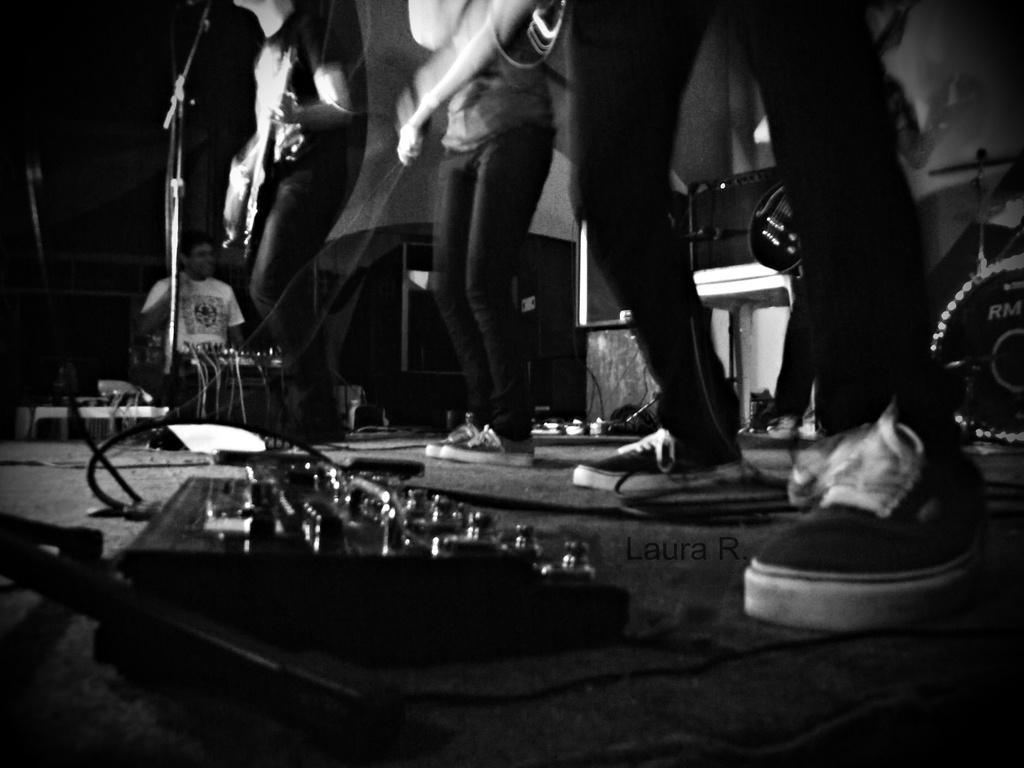Could you give a brief overview of what you see in this image? This picture shows three members were standing on the floor. There is a musical instrument placed on the floor. Here is a microphone and a stand here. One guy is playing the guitar in the background. 